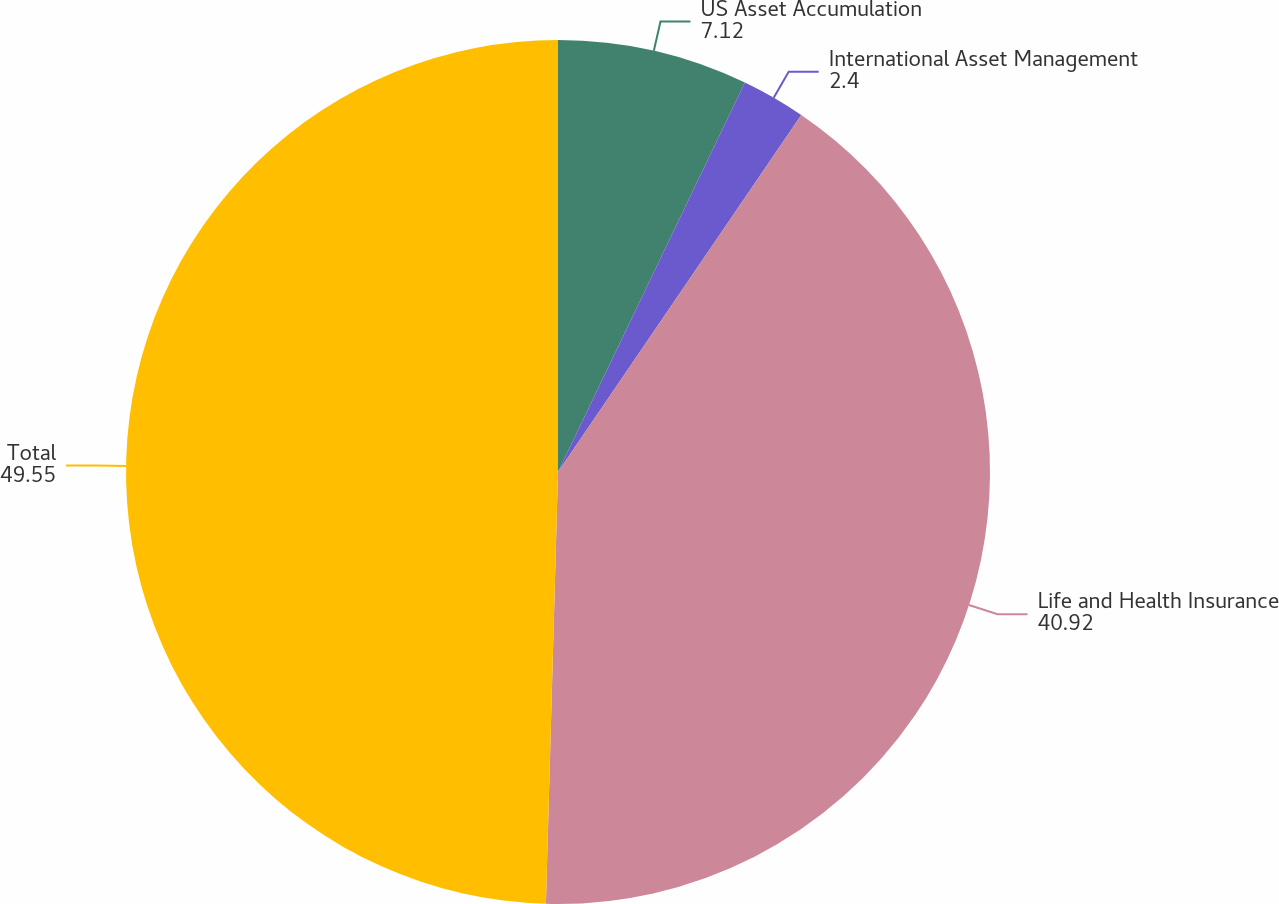Convert chart to OTSL. <chart><loc_0><loc_0><loc_500><loc_500><pie_chart><fcel>US Asset Accumulation<fcel>International Asset Management<fcel>Life and Health Insurance<fcel>Total<nl><fcel>7.12%<fcel>2.4%<fcel>40.92%<fcel>49.55%<nl></chart> 